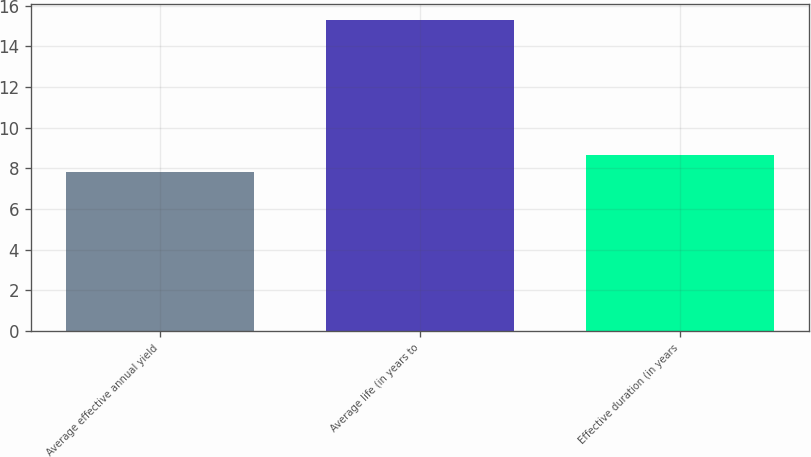<chart> <loc_0><loc_0><loc_500><loc_500><bar_chart><fcel>Average effective annual yield<fcel>Average life (in years to<fcel>Effective duration (in years<nl><fcel>7.83<fcel>15.3<fcel>8.66<nl></chart> 